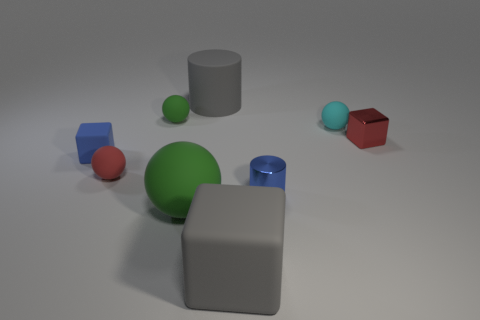Subtract all cyan matte balls. How many balls are left? 3 Add 1 tiny blue balls. How many objects exist? 10 Subtract all gray blocks. How many green balls are left? 2 Subtract all blue cubes. How many cubes are left? 2 Subtract all cylinders. How many objects are left? 7 Subtract 2 balls. How many balls are left? 2 Add 6 small matte blocks. How many small matte blocks exist? 7 Subtract 0 red cylinders. How many objects are left? 9 Subtract all red cubes. Subtract all green cylinders. How many cubes are left? 2 Subtract all small yellow metallic balls. Subtract all tiny blue cylinders. How many objects are left? 8 